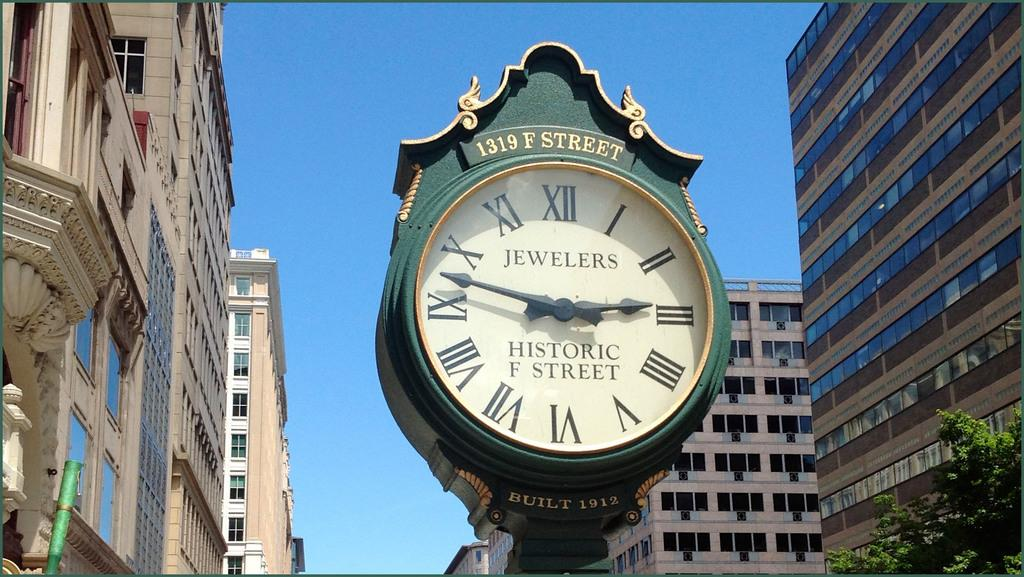What is the main subject in the middle of the image? There is a clock in the middle of the image. What colors are used for the clock? The clock is in yellow and green colors. What structures are on either side of the clock? There are buildings on either side of the clock. What type of vegetation is on the right side of the image? There are trees on the right side of the image. What is visible at the top of the image? The sky is visible at the top of the image. How many members are on the team playing on the hill in the image? There is no team or hill present in the image; it features a clock with buildings and trees. What type of bulb is used to light up the clock in the image? There is no information about the clock's lighting source in the image, and therefore no such bulb can be identified. 